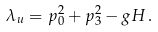Convert formula to latex. <formula><loc_0><loc_0><loc_500><loc_500>\lambda _ { u } = p _ { 0 } ^ { 2 } + p _ { 3 } ^ { 2 } - g H \, .</formula> 